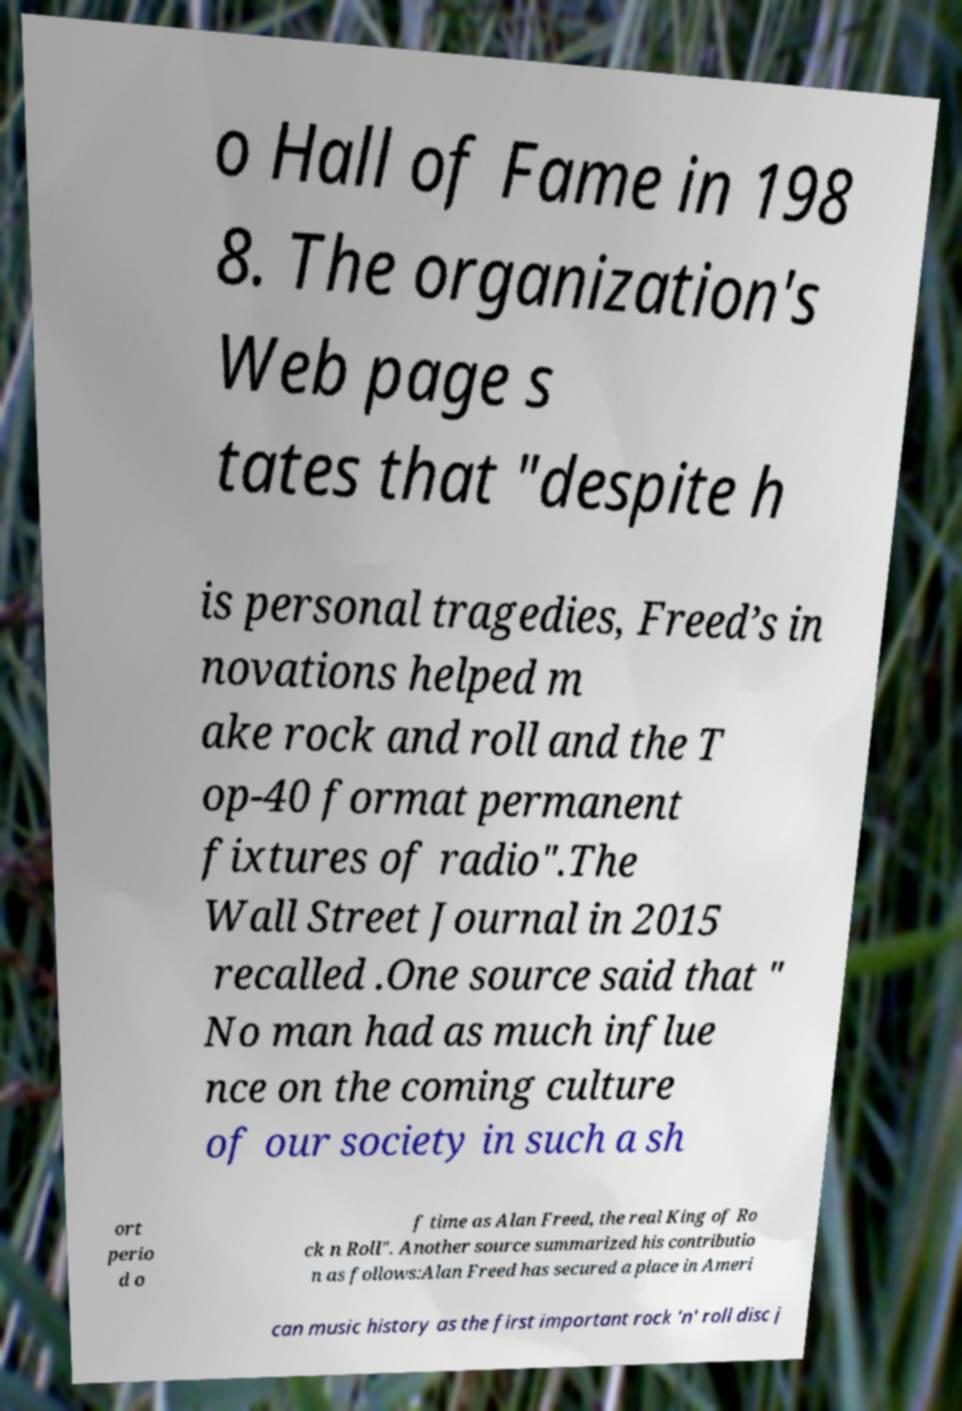Can you read and provide the text displayed in the image?This photo seems to have some interesting text. Can you extract and type it out for me? o Hall of Fame in 198 8. The organization's Web page s tates that "despite h is personal tragedies, Freed’s in novations helped m ake rock and roll and the T op-40 format permanent fixtures of radio".The Wall Street Journal in 2015 recalled .One source said that " No man had as much influe nce on the coming culture of our society in such a sh ort perio d o f time as Alan Freed, the real King of Ro ck n Roll". Another source summarized his contributio n as follows:Alan Freed has secured a place in Ameri can music history as the first important rock 'n' roll disc j 